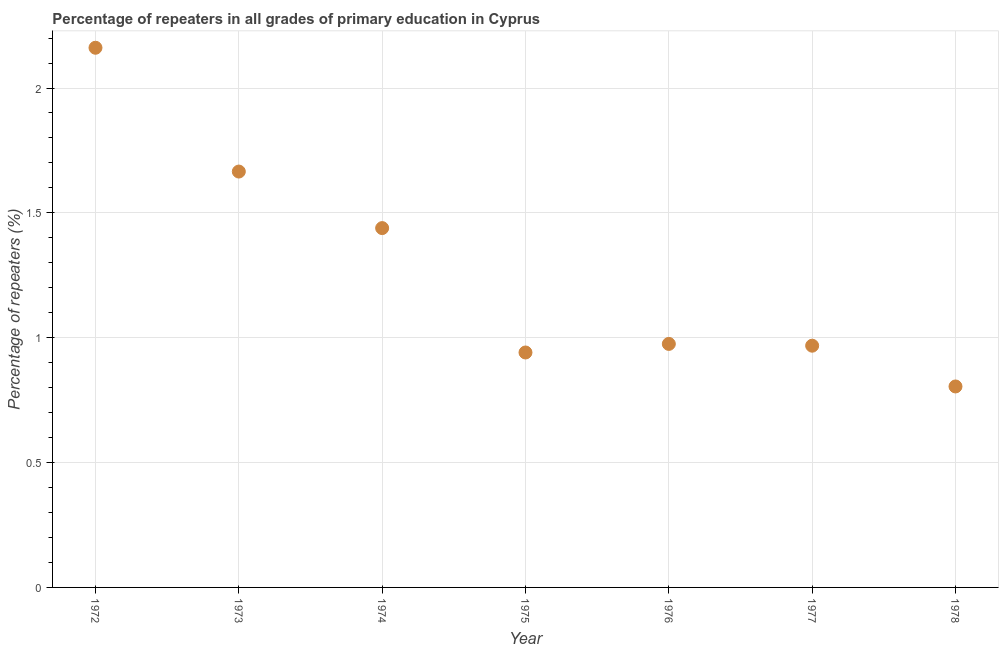What is the percentage of repeaters in primary education in 1973?
Your response must be concise. 1.67. Across all years, what is the maximum percentage of repeaters in primary education?
Your response must be concise. 2.16. Across all years, what is the minimum percentage of repeaters in primary education?
Your answer should be compact. 0.8. In which year was the percentage of repeaters in primary education minimum?
Ensure brevity in your answer.  1978. What is the sum of the percentage of repeaters in primary education?
Ensure brevity in your answer.  8.95. What is the difference between the percentage of repeaters in primary education in 1975 and 1977?
Offer a very short reply. -0.03. What is the average percentage of repeaters in primary education per year?
Your response must be concise. 1.28. What is the median percentage of repeaters in primary education?
Offer a very short reply. 0.98. What is the ratio of the percentage of repeaters in primary education in 1975 to that in 1978?
Your answer should be very brief. 1.17. Is the percentage of repeaters in primary education in 1973 less than that in 1977?
Provide a short and direct response. No. What is the difference between the highest and the second highest percentage of repeaters in primary education?
Offer a terse response. 0.5. Is the sum of the percentage of repeaters in primary education in 1972 and 1975 greater than the maximum percentage of repeaters in primary education across all years?
Make the answer very short. Yes. What is the difference between the highest and the lowest percentage of repeaters in primary education?
Provide a short and direct response. 1.36. In how many years, is the percentage of repeaters in primary education greater than the average percentage of repeaters in primary education taken over all years?
Your answer should be very brief. 3. How many years are there in the graph?
Make the answer very short. 7. Are the values on the major ticks of Y-axis written in scientific E-notation?
Keep it short and to the point. No. Does the graph contain any zero values?
Ensure brevity in your answer.  No. Does the graph contain grids?
Provide a short and direct response. Yes. What is the title of the graph?
Offer a very short reply. Percentage of repeaters in all grades of primary education in Cyprus. What is the label or title of the X-axis?
Provide a succinct answer. Year. What is the label or title of the Y-axis?
Your answer should be compact. Percentage of repeaters (%). What is the Percentage of repeaters (%) in 1972?
Make the answer very short. 2.16. What is the Percentage of repeaters (%) in 1973?
Give a very brief answer. 1.67. What is the Percentage of repeaters (%) in 1974?
Offer a terse response. 1.44. What is the Percentage of repeaters (%) in 1975?
Keep it short and to the point. 0.94. What is the Percentage of repeaters (%) in 1976?
Ensure brevity in your answer.  0.98. What is the Percentage of repeaters (%) in 1977?
Offer a very short reply. 0.97. What is the Percentage of repeaters (%) in 1978?
Offer a very short reply. 0.8. What is the difference between the Percentage of repeaters (%) in 1972 and 1973?
Provide a short and direct response. 0.5. What is the difference between the Percentage of repeaters (%) in 1972 and 1974?
Keep it short and to the point. 0.72. What is the difference between the Percentage of repeaters (%) in 1972 and 1975?
Your answer should be compact. 1.22. What is the difference between the Percentage of repeaters (%) in 1972 and 1976?
Your answer should be compact. 1.19. What is the difference between the Percentage of repeaters (%) in 1972 and 1977?
Offer a very short reply. 1.19. What is the difference between the Percentage of repeaters (%) in 1972 and 1978?
Provide a succinct answer. 1.36. What is the difference between the Percentage of repeaters (%) in 1973 and 1974?
Give a very brief answer. 0.23. What is the difference between the Percentage of repeaters (%) in 1973 and 1975?
Give a very brief answer. 0.72. What is the difference between the Percentage of repeaters (%) in 1973 and 1976?
Provide a succinct answer. 0.69. What is the difference between the Percentage of repeaters (%) in 1973 and 1977?
Offer a very short reply. 0.7. What is the difference between the Percentage of repeaters (%) in 1973 and 1978?
Ensure brevity in your answer.  0.86. What is the difference between the Percentage of repeaters (%) in 1974 and 1975?
Offer a terse response. 0.5. What is the difference between the Percentage of repeaters (%) in 1974 and 1976?
Give a very brief answer. 0.46. What is the difference between the Percentage of repeaters (%) in 1974 and 1977?
Your answer should be very brief. 0.47. What is the difference between the Percentage of repeaters (%) in 1974 and 1978?
Your response must be concise. 0.63. What is the difference between the Percentage of repeaters (%) in 1975 and 1976?
Your answer should be compact. -0.03. What is the difference between the Percentage of repeaters (%) in 1975 and 1977?
Offer a terse response. -0.03. What is the difference between the Percentage of repeaters (%) in 1975 and 1978?
Your answer should be very brief. 0.14. What is the difference between the Percentage of repeaters (%) in 1976 and 1977?
Offer a terse response. 0.01. What is the difference between the Percentage of repeaters (%) in 1976 and 1978?
Provide a short and direct response. 0.17. What is the difference between the Percentage of repeaters (%) in 1977 and 1978?
Offer a terse response. 0.16. What is the ratio of the Percentage of repeaters (%) in 1972 to that in 1973?
Your response must be concise. 1.3. What is the ratio of the Percentage of repeaters (%) in 1972 to that in 1974?
Your answer should be compact. 1.5. What is the ratio of the Percentage of repeaters (%) in 1972 to that in 1975?
Your answer should be very brief. 2.3. What is the ratio of the Percentage of repeaters (%) in 1972 to that in 1976?
Keep it short and to the point. 2.22. What is the ratio of the Percentage of repeaters (%) in 1972 to that in 1977?
Ensure brevity in your answer.  2.23. What is the ratio of the Percentage of repeaters (%) in 1972 to that in 1978?
Provide a short and direct response. 2.69. What is the ratio of the Percentage of repeaters (%) in 1973 to that in 1974?
Give a very brief answer. 1.16. What is the ratio of the Percentage of repeaters (%) in 1973 to that in 1975?
Keep it short and to the point. 1.77. What is the ratio of the Percentage of repeaters (%) in 1973 to that in 1976?
Your answer should be very brief. 1.71. What is the ratio of the Percentage of repeaters (%) in 1973 to that in 1977?
Provide a succinct answer. 1.72. What is the ratio of the Percentage of repeaters (%) in 1973 to that in 1978?
Ensure brevity in your answer.  2.07. What is the ratio of the Percentage of repeaters (%) in 1974 to that in 1975?
Your response must be concise. 1.53. What is the ratio of the Percentage of repeaters (%) in 1974 to that in 1976?
Give a very brief answer. 1.48. What is the ratio of the Percentage of repeaters (%) in 1974 to that in 1977?
Your answer should be very brief. 1.49. What is the ratio of the Percentage of repeaters (%) in 1974 to that in 1978?
Give a very brief answer. 1.79. What is the ratio of the Percentage of repeaters (%) in 1975 to that in 1976?
Offer a terse response. 0.96. What is the ratio of the Percentage of repeaters (%) in 1975 to that in 1978?
Your response must be concise. 1.17. What is the ratio of the Percentage of repeaters (%) in 1976 to that in 1977?
Your answer should be very brief. 1.01. What is the ratio of the Percentage of repeaters (%) in 1976 to that in 1978?
Provide a short and direct response. 1.21. What is the ratio of the Percentage of repeaters (%) in 1977 to that in 1978?
Offer a terse response. 1.2. 